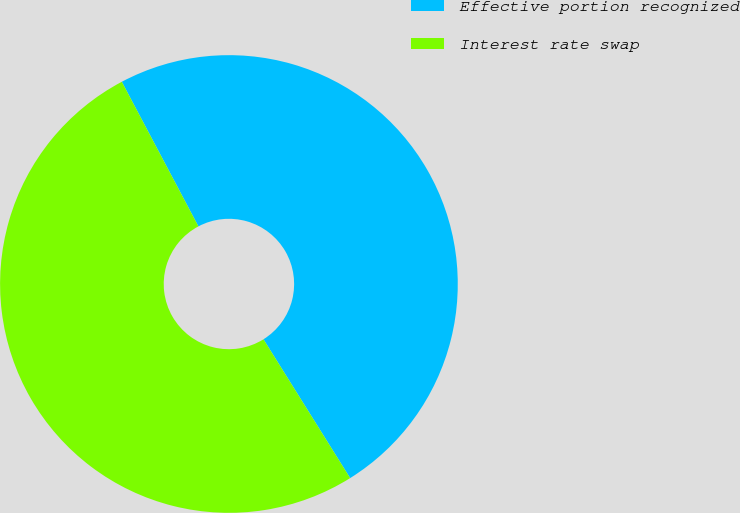<chart> <loc_0><loc_0><loc_500><loc_500><pie_chart><fcel>Effective portion recognized<fcel>Interest rate swap<nl><fcel>48.87%<fcel>51.13%<nl></chart> 